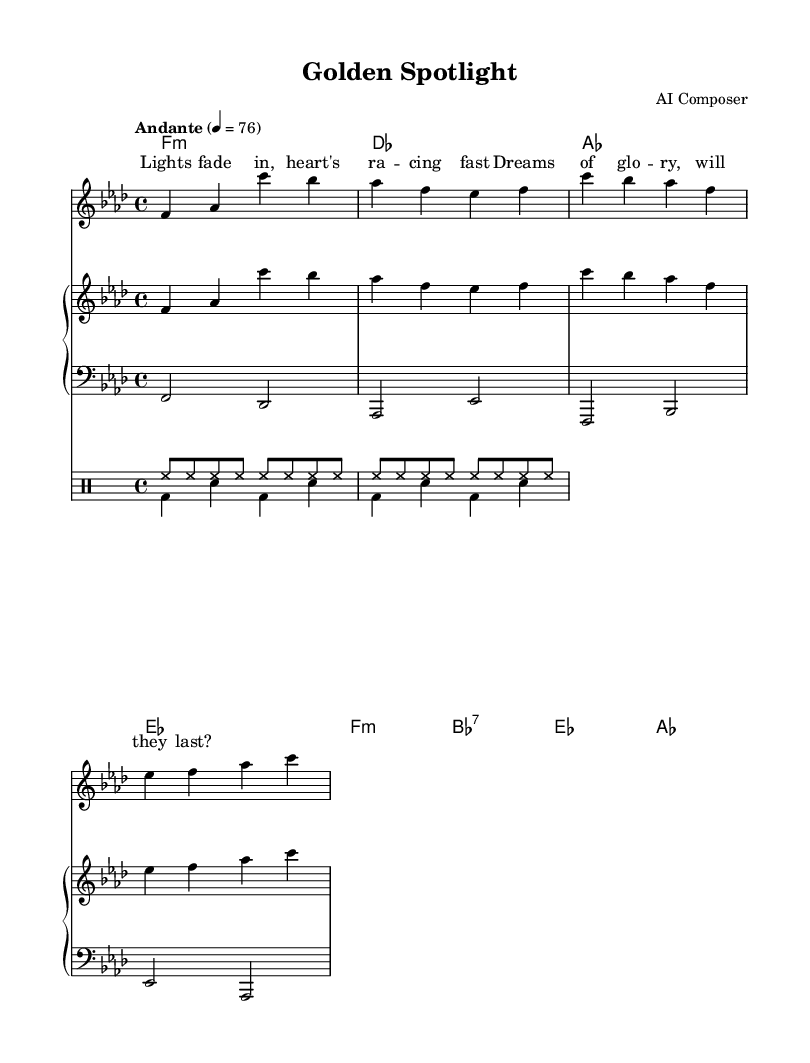What is the key signature of this music? The key signature is indicated by the symbols at the beginning of the staff. Since there are four flats, the key is F minor.
Answer: F minor What is the time signature of this piece? The time signature is found on the left side of the staff, indicating the number of beats in a measure. It shows 4 over 4, which means there are four beats per measure.
Answer: 4/4 What is the tempo marking of the piece? The tempo marking appears in text format at the start of the score. It is described as "Andante" with a specific metronome marking of 76 beats per minute, guiding the performance speed.
Answer: Andante 4 = 76 How many measures are in the melody section? The melody section consists of a series of measures defined by vertical lines. Counting each of these lines indicates there are four measures in this melody.
Answer: 4 What is the overall mood reflected in the lyrics? The lyrics express feelings of uncertainty and longing, as indicated by phrases like "Lights fade in" and "will they last?" which suggest a contemplative and emotional tone typical of soul music.
Answer: Emotional What chord is played in the second measure of the harmonies section? In the harmonies section, to identify the specific chord, one must refer to the second group of notes which shows the chord symbols. The second measure shows a D-flat major chord (des).
Answer: D-flat major What element distinguishes this piece as Soul music? Soul music is characterized by its emotive expression and depth, often reflecting personal struggles and triumphs. This piece captures that essence through reflective lyrics and a melancholic melody.
Answer: Emotive expression 